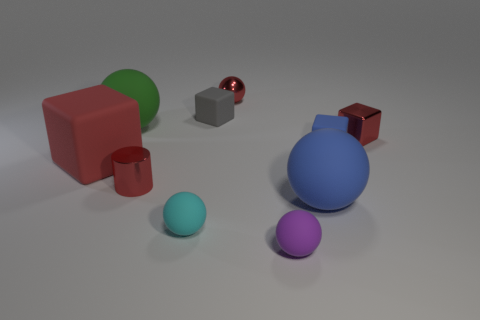Are there any tiny blocks made of the same material as the big blue sphere?
Offer a very short reply. Yes. There is a blue matte object behind the large blue rubber sphere; does it have the same shape as the small cyan thing?
Give a very brief answer. No. There is a big object that is on the right side of the tiny metallic sphere on the right side of the green ball; how many small purple rubber balls are behind it?
Offer a terse response. 0. Are there fewer green rubber things in front of the large green matte ball than small balls behind the tiny blue matte thing?
Offer a very short reply. Yes. There is another big matte object that is the same shape as the gray thing; what color is it?
Your answer should be compact. Red. What is the size of the blue rubber sphere?
Your answer should be compact. Large. How many purple spheres are the same size as the green rubber sphere?
Give a very brief answer. 0. Do the metal cube and the small cylinder have the same color?
Provide a short and direct response. Yes. Is the material of the tiny ball behind the large green object the same as the small red object that is right of the small purple object?
Provide a succinct answer. Yes. Is the number of matte cylinders greater than the number of spheres?
Your answer should be very brief. No. 